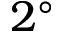Convert formula to latex. <formula><loc_0><loc_0><loc_500><loc_500>2 ^ { \circ }</formula> 